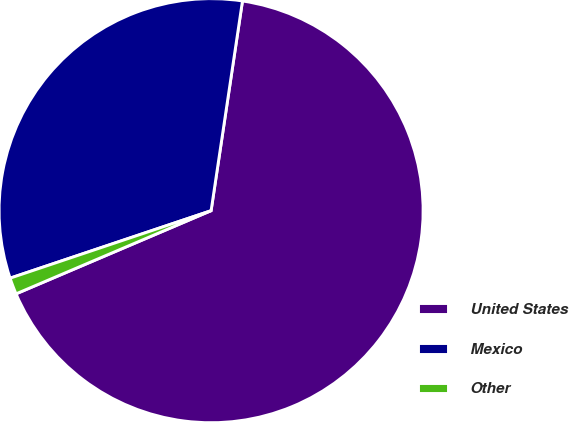<chart> <loc_0><loc_0><loc_500><loc_500><pie_chart><fcel>United States<fcel>Mexico<fcel>Other<nl><fcel>66.22%<fcel>32.52%<fcel>1.26%<nl></chart> 